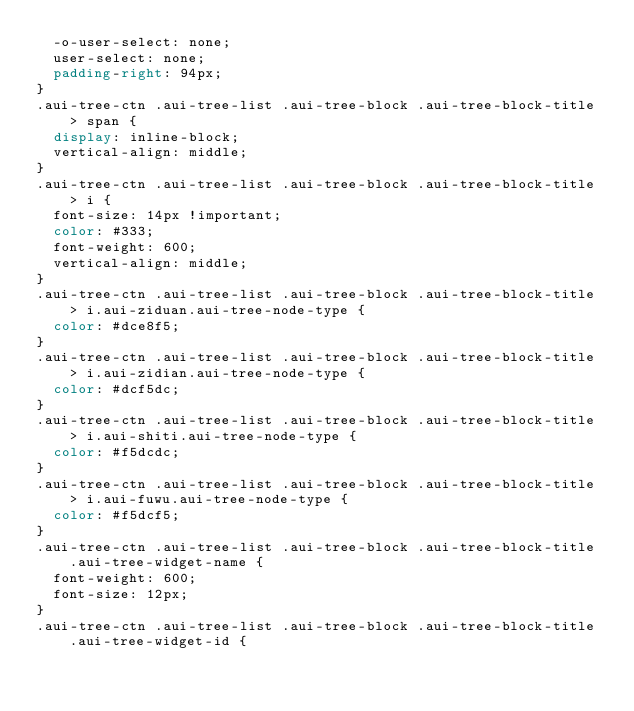Convert code to text. <code><loc_0><loc_0><loc_500><loc_500><_CSS_>  -o-user-select: none;
  user-select: none;
  padding-right: 94px;
}
.aui-tree-ctn .aui-tree-list .aui-tree-block .aui-tree-block-title > span {
  display: inline-block;
  vertical-align: middle;
}
.aui-tree-ctn .aui-tree-list .aui-tree-block .aui-tree-block-title > i {
  font-size: 14px !important;
  color: #333;
  font-weight: 600;
  vertical-align: middle;
}
.aui-tree-ctn .aui-tree-list .aui-tree-block .aui-tree-block-title > i.aui-ziduan.aui-tree-node-type {
  color: #dce8f5;
}
.aui-tree-ctn .aui-tree-list .aui-tree-block .aui-tree-block-title > i.aui-zidian.aui-tree-node-type {
  color: #dcf5dc;
}
.aui-tree-ctn .aui-tree-list .aui-tree-block .aui-tree-block-title > i.aui-shiti.aui-tree-node-type {
  color: #f5dcdc;
}
.aui-tree-ctn .aui-tree-list .aui-tree-block .aui-tree-block-title > i.aui-fuwu.aui-tree-node-type {
  color: #f5dcf5;
}
.aui-tree-ctn .aui-tree-list .aui-tree-block .aui-tree-block-title .aui-tree-widget-name {
  font-weight: 600;
  font-size: 12px;
}
.aui-tree-ctn .aui-tree-list .aui-tree-block .aui-tree-block-title .aui-tree-widget-id {</code> 